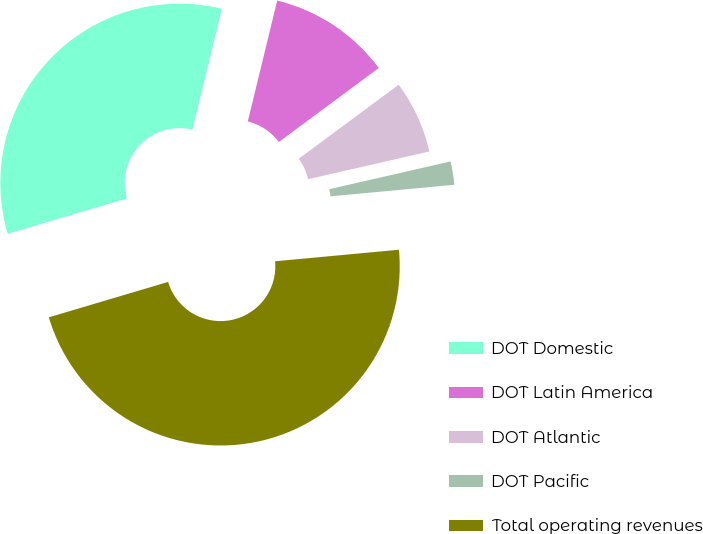Convert chart. <chart><loc_0><loc_0><loc_500><loc_500><pie_chart><fcel>DOT Domestic<fcel>DOT Latin America<fcel>DOT Atlantic<fcel>DOT Pacific<fcel>Total operating revenues<nl><fcel>33.39%<fcel>11.05%<fcel>6.57%<fcel>2.1%<fcel>46.88%<nl></chart> 